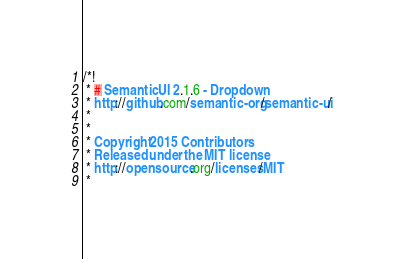Convert code to text. <code><loc_0><loc_0><loc_500><loc_500><_CSS_>/*!
 * # Semantic UI 2.1.6 - Dropdown
 * http://github.com/semantic-org/semantic-ui/
 *
 *
 * Copyright 2015 Contributors
 * Released under the MIT license
 * http://opensource.org/licenses/MIT
 *</code> 